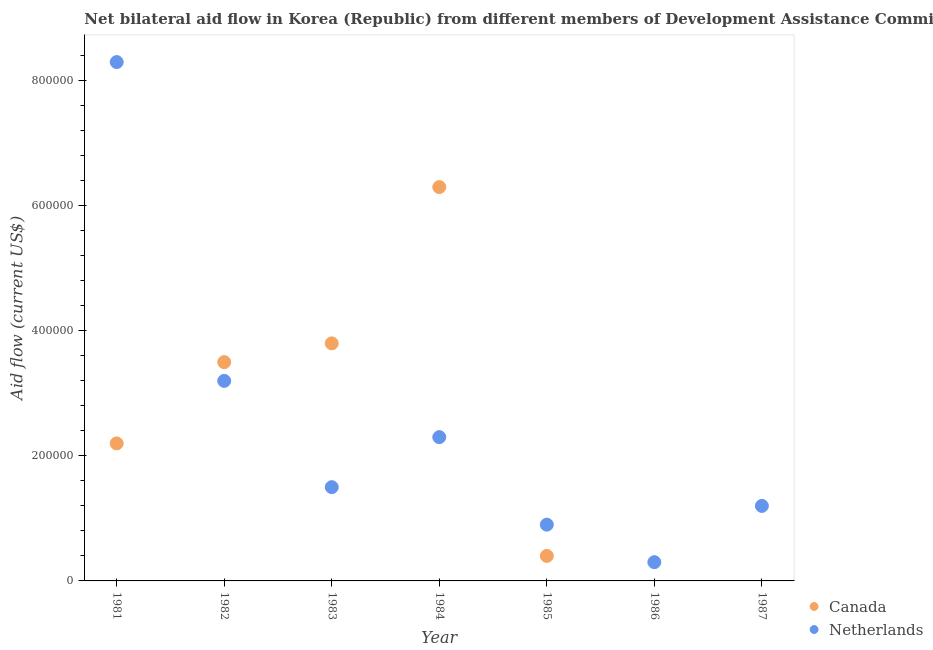What is the amount of aid given by canada in 1981?
Your response must be concise. 2.20e+05. Across all years, what is the maximum amount of aid given by netherlands?
Give a very brief answer. 8.30e+05. Across all years, what is the minimum amount of aid given by netherlands?
Your response must be concise. 3.00e+04. What is the total amount of aid given by netherlands in the graph?
Make the answer very short. 1.77e+06. What is the difference between the amount of aid given by canada in 1981 and that in 1984?
Offer a very short reply. -4.10e+05. What is the difference between the amount of aid given by canada in 1983 and the amount of aid given by netherlands in 1984?
Your answer should be very brief. 1.50e+05. What is the average amount of aid given by canada per year?
Keep it short and to the point. 2.31e+05. In the year 1985, what is the difference between the amount of aid given by canada and amount of aid given by netherlands?
Your answer should be compact. -5.00e+04. In how many years, is the amount of aid given by netherlands greater than 440000 US$?
Make the answer very short. 1. What is the ratio of the amount of aid given by netherlands in 1982 to that in 1986?
Offer a very short reply. 10.67. Is the amount of aid given by netherlands in 1981 less than that in 1987?
Your response must be concise. No. Is the difference between the amount of aid given by netherlands in 1982 and 1983 greater than the difference between the amount of aid given by canada in 1982 and 1983?
Keep it short and to the point. Yes. What is the difference between the highest and the second highest amount of aid given by canada?
Your response must be concise. 2.50e+05. What is the difference between the highest and the lowest amount of aid given by canada?
Your answer should be very brief. 6.30e+05. In how many years, is the amount of aid given by canada greater than the average amount of aid given by canada taken over all years?
Your answer should be compact. 3. Is the amount of aid given by netherlands strictly greater than the amount of aid given by canada over the years?
Your response must be concise. No. Is the amount of aid given by netherlands strictly less than the amount of aid given by canada over the years?
Give a very brief answer. No. How many years are there in the graph?
Keep it short and to the point. 7. Are the values on the major ticks of Y-axis written in scientific E-notation?
Make the answer very short. No. Does the graph contain any zero values?
Provide a short and direct response. Yes. Does the graph contain grids?
Your response must be concise. No. What is the title of the graph?
Ensure brevity in your answer.  Net bilateral aid flow in Korea (Republic) from different members of Development Assistance Committee. Does "Foreign liabilities" appear as one of the legend labels in the graph?
Offer a very short reply. No. What is the label or title of the X-axis?
Your response must be concise. Year. What is the label or title of the Y-axis?
Give a very brief answer. Aid flow (current US$). What is the Aid flow (current US$) in Canada in 1981?
Keep it short and to the point. 2.20e+05. What is the Aid flow (current US$) of Netherlands in 1981?
Your response must be concise. 8.30e+05. What is the Aid flow (current US$) in Canada in 1982?
Ensure brevity in your answer.  3.50e+05. What is the Aid flow (current US$) of Netherlands in 1982?
Offer a very short reply. 3.20e+05. What is the Aid flow (current US$) of Canada in 1983?
Keep it short and to the point. 3.80e+05. What is the Aid flow (current US$) of Canada in 1984?
Make the answer very short. 6.30e+05. What is the Aid flow (current US$) of Canada in 1986?
Provide a short and direct response. 0. What is the Aid flow (current US$) in Netherlands in 1987?
Give a very brief answer. 1.20e+05. Across all years, what is the maximum Aid flow (current US$) in Canada?
Provide a short and direct response. 6.30e+05. Across all years, what is the maximum Aid flow (current US$) of Netherlands?
Ensure brevity in your answer.  8.30e+05. Across all years, what is the minimum Aid flow (current US$) in Netherlands?
Offer a very short reply. 3.00e+04. What is the total Aid flow (current US$) of Canada in the graph?
Your answer should be compact. 1.62e+06. What is the total Aid flow (current US$) in Netherlands in the graph?
Ensure brevity in your answer.  1.77e+06. What is the difference between the Aid flow (current US$) in Netherlands in 1981 and that in 1982?
Give a very brief answer. 5.10e+05. What is the difference between the Aid flow (current US$) of Netherlands in 1981 and that in 1983?
Your response must be concise. 6.80e+05. What is the difference between the Aid flow (current US$) in Canada in 1981 and that in 1984?
Your response must be concise. -4.10e+05. What is the difference between the Aid flow (current US$) of Canada in 1981 and that in 1985?
Offer a terse response. 1.80e+05. What is the difference between the Aid flow (current US$) in Netherlands in 1981 and that in 1985?
Give a very brief answer. 7.40e+05. What is the difference between the Aid flow (current US$) in Netherlands in 1981 and that in 1987?
Give a very brief answer. 7.10e+05. What is the difference between the Aid flow (current US$) in Netherlands in 1982 and that in 1983?
Your answer should be compact. 1.70e+05. What is the difference between the Aid flow (current US$) of Canada in 1982 and that in 1984?
Keep it short and to the point. -2.80e+05. What is the difference between the Aid flow (current US$) of Netherlands in 1982 and that in 1986?
Provide a short and direct response. 2.90e+05. What is the difference between the Aid flow (current US$) of Canada in 1983 and that in 1984?
Ensure brevity in your answer.  -2.50e+05. What is the difference between the Aid flow (current US$) of Netherlands in 1983 and that in 1986?
Your answer should be very brief. 1.20e+05. What is the difference between the Aid flow (current US$) in Canada in 1984 and that in 1985?
Provide a short and direct response. 5.90e+05. What is the difference between the Aid flow (current US$) of Netherlands in 1984 and that in 1986?
Keep it short and to the point. 2.00e+05. What is the difference between the Aid flow (current US$) of Netherlands in 1985 and that in 1986?
Give a very brief answer. 6.00e+04. What is the difference between the Aid flow (current US$) of Canada in 1981 and the Aid flow (current US$) of Netherlands in 1982?
Offer a very short reply. -1.00e+05. What is the difference between the Aid flow (current US$) in Canada in 1981 and the Aid flow (current US$) in Netherlands in 1985?
Make the answer very short. 1.30e+05. What is the difference between the Aid flow (current US$) of Canada in 1982 and the Aid flow (current US$) of Netherlands in 1983?
Provide a short and direct response. 2.00e+05. What is the difference between the Aid flow (current US$) in Canada in 1982 and the Aid flow (current US$) in Netherlands in 1984?
Offer a very short reply. 1.20e+05. What is the difference between the Aid flow (current US$) in Canada in 1982 and the Aid flow (current US$) in Netherlands in 1985?
Give a very brief answer. 2.60e+05. What is the difference between the Aid flow (current US$) of Canada in 1983 and the Aid flow (current US$) of Netherlands in 1984?
Make the answer very short. 1.50e+05. What is the difference between the Aid flow (current US$) in Canada in 1983 and the Aid flow (current US$) in Netherlands in 1985?
Your answer should be compact. 2.90e+05. What is the difference between the Aid flow (current US$) of Canada in 1984 and the Aid flow (current US$) of Netherlands in 1985?
Make the answer very short. 5.40e+05. What is the difference between the Aid flow (current US$) of Canada in 1984 and the Aid flow (current US$) of Netherlands in 1987?
Provide a short and direct response. 5.10e+05. What is the average Aid flow (current US$) in Canada per year?
Ensure brevity in your answer.  2.31e+05. What is the average Aid flow (current US$) in Netherlands per year?
Provide a short and direct response. 2.53e+05. In the year 1981, what is the difference between the Aid flow (current US$) in Canada and Aid flow (current US$) in Netherlands?
Your answer should be very brief. -6.10e+05. In the year 1982, what is the difference between the Aid flow (current US$) in Canada and Aid flow (current US$) in Netherlands?
Your response must be concise. 3.00e+04. In the year 1983, what is the difference between the Aid flow (current US$) of Canada and Aid flow (current US$) of Netherlands?
Ensure brevity in your answer.  2.30e+05. What is the ratio of the Aid flow (current US$) of Canada in 1981 to that in 1982?
Provide a succinct answer. 0.63. What is the ratio of the Aid flow (current US$) in Netherlands in 1981 to that in 1982?
Ensure brevity in your answer.  2.59. What is the ratio of the Aid flow (current US$) in Canada in 1981 to that in 1983?
Provide a succinct answer. 0.58. What is the ratio of the Aid flow (current US$) of Netherlands in 1981 to that in 1983?
Provide a succinct answer. 5.53. What is the ratio of the Aid flow (current US$) in Canada in 1981 to that in 1984?
Provide a short and direct response. 0.35. What is the ratio of the Aid flow (current US$) in Netherlands in 1981 to that in 1984?
Ensure brevity in your answer.  3.61. What is the ratio of the Aid flow (current US$) of Canada in 1981 to that in 1985?
Make the answer very short. 5.5. What is the ratio of the Aid flow (current US$) of Netherlands in 1981 to that in 1985?
Your response must be concise. 9.22. What is the ratio of the Aid flow (current US$) in Netherlands in 1981 to that in 1986?
Keep it short and to the point. 27.67. What is the ratio of the Aid flow (current US$) in Netherlands in 1981 to that in 1987?
Ensure brevity in your answer.  6.92. What is the ratio of the Aid flow (current US$) in Canada in 1982 to that in 1983?
Your response must be concise. 0.92. What is the ratio of the Aid flow (current US$) of Netherlands in 1982 to that in 1983?
Your response must be concise. 2.13. What is the ratio of the Aid flow (current US$) in Canada in 1982 to that in 1984?
Ensure brevity in your answer.  0.56. What is the ratio of the Aid flow (current US$) of Netherlands in 1982 to that in 1984?
Give a very brief answer. 1.39. What is the ratio of the Aid flow (current US$) of Canada in 1982 to that in 1985?
Your answer should be very brief. 8.75. What is the ratio of the Aid flow (current US$) of Netherlands in 1982 to that in 1985?
Your response must be concise. 3.56. What is the ratio of the Aid flow (current US$) in Netherlands in 1982 to that in 1986?
Give a very brief answer. 10.67. What is the ratio of the Aid flow (current US$) of Netherlands in 1982 to that in 1987?
Make the answer very short. 2.67. What is the ratio of the Aid flow (current US$) of Canada in 1983 to that in 1984?
Offer a terse response. 0.6. What is the ratio of the Aid flow (current US$) in Netherlands in 1983 to that in 1984?
Offer a terse response. 0.65. What is the ratio of the Aid flow (current US$) in Canada in 1983 to that in 1985?
Ensure brevity in your answer.  9.5. What is the ratio of the Aid flow (current US$) in Netherlands in 1983 to that in 1985?
Make the answer very short. 1.67. What is the ratio of the Aid flow (current US$) in Netherlands in 1983 to that in 1987?
Offer a terse response. 1.25. What is the ratio of the Aid flow (current US$) of Canada in 1984 to that in 1985?
Offer a terse response. 15.75. What is the ratio of the Aid flow (current US$) in Netherlands in 1984 to that in 1985?
Make the answer very short. 2.56. What is the ratio of the Aid flow (current US$) in Netherlands in 1984 to that in 1986?
Your answer should be compact. 7.67. What is the ratio of the Aid flow (current US$) in Netherlands in 1984 to that in 1987?
Provide a succinct answer. 1.92. What is the difference between the highest and the second highest Aid flow (current US$) in Netherlands?
Make the answer very short. 5.10e+05. What is the difference between the highest and the lowest Aid flow (current US$) of Canada?
Your answer should be compact. 6.30e+05. 